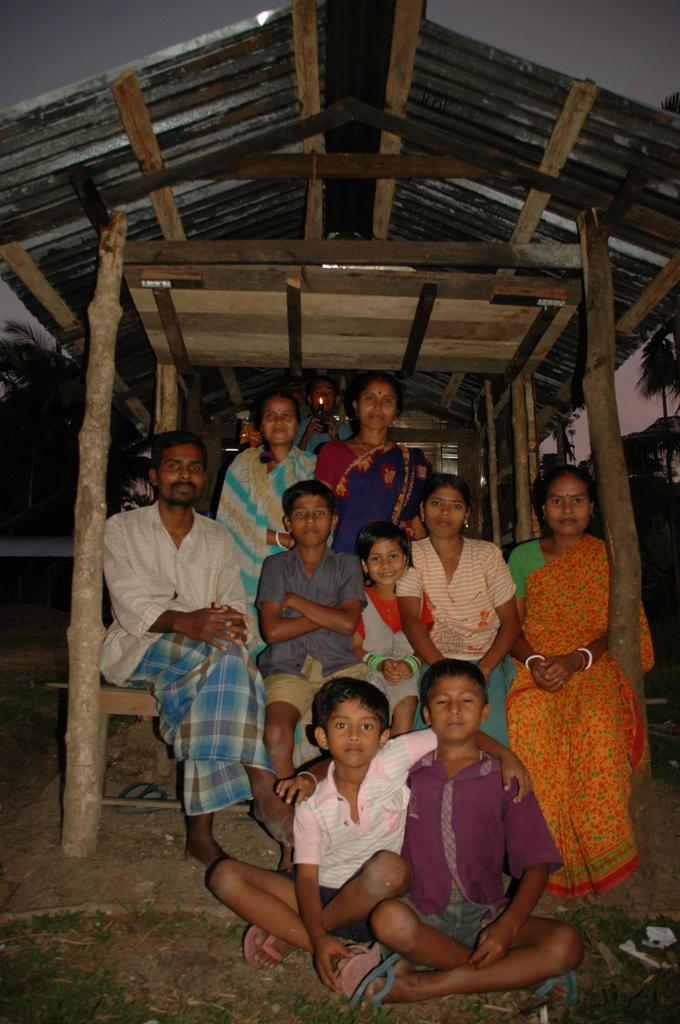What is the main subject in the middle of the image? There is a group of people in the middle of the image. What type of vegetation can be seen on the left side of the image? There are trees on the left side of the image. What materials are present at the top of the image? There are metal sheets and wooden sticks at the top of the image. How much distance has the group of people traveled to reach the front of the image? There is no information about the group of people's movement or distance traveled in the image. What is the growth rate of the trees on the left side of the image? The growth rate of the trees cannot be determined from the image alone. 